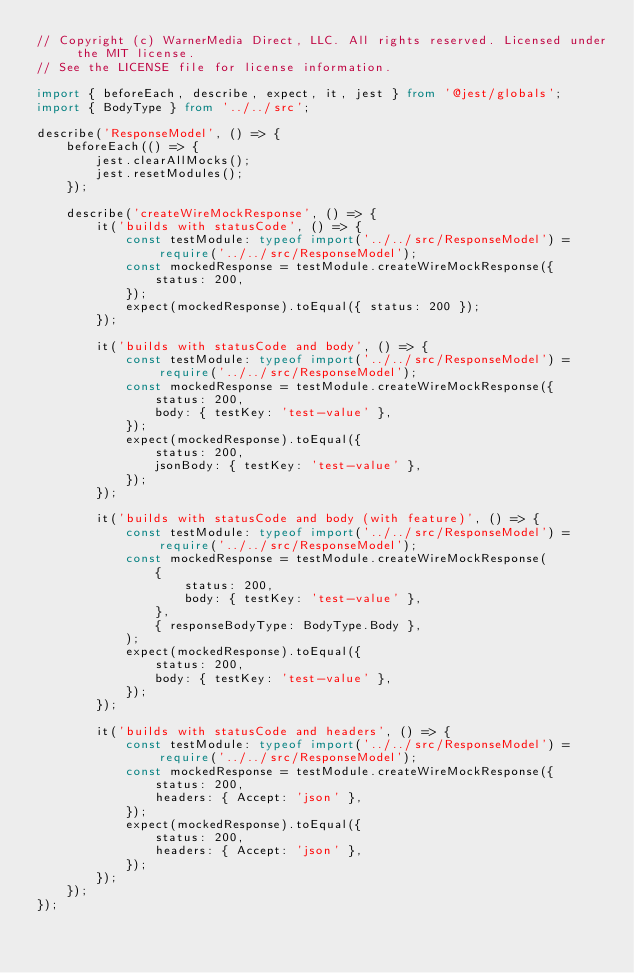<code> <loc_0><loc_0><loc_500><loc_500><_TypeScript_>// Copyright (c) WarnerMedia Direct, LLC. All rights reserved. Licensed under the MIT license.
// See the LICENSE file for license information.

import { beforeEach, describe, expect, it, jest } from '@jest/globals';
import { BodyType } from '../../src';

describe('ResponseModel', () => {
    beforeEach(() => {
        jest.clearAllMocks();
        jest.resetModules();
    });

    describe('createWireMockResponse', () => {
        it('builds with statusCode', () => {
            const testModule: typeof import('../../src/ResponseModel') = require('../../src/ResponseModel');
            const mockedResponse = testModule.createWireMockResponse({
                status: 200,
            });
            expect(mockedResponse).toEqual({ status: 200 });
        });

        it('builds with statusCode and body', () => {
            const testModule: typeof import('../../src/ResponseModel') = require('../../src/ResponseModel');
            const mockedResponse = testModule.createWireMockResponse({
                status: 200,
                body: { testKey: 'test-value' },
            });
            expect(mockedResponse).toEqual({
                status: 200,
                jsonBody: { testKey: 'test-value' },
            });
        });

        it('builds with statusCode and body (with feature)', () => {
            const testModule: typeof import('../../src/ResponseModel') = require('../../src/ResponseModel');
            const mockedResponse = testModule.createWireMockResponse(
                {
                    status: 200,
                    body: { testKey: 'test-value' },
                },
                { responseBodyType: BodyType.Body },
            );
            expect(mockedResponse).toEqual({
                status: 200,
                body: { testKey: 'test-value' },
            });
        });

        it('builds with statusCode and headers', () => {
            const testModule: typeof import('../../src/ResponseModel') = require('../../src/ResponseModel');
            const mockedResponse = testModule.createWireMockResponse({
                status: 200,
                headers: { Accept: 'json' },
            });
            expect(mockedResponse).toEqual({
                status: 200,
                headers: { Accept: 'json' },
            });
        });
    });
});
</code> 